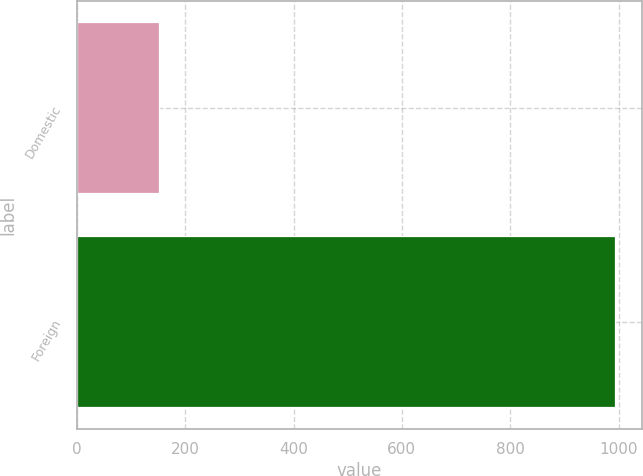Convert chart to OTSL. <chart><loc_0><loc_0><loc_500><loc_500><bar_chart><fcel>Domestic<fcel>Foreign<nl><fcel>151.4<fcel>993.8<nl></chart> 